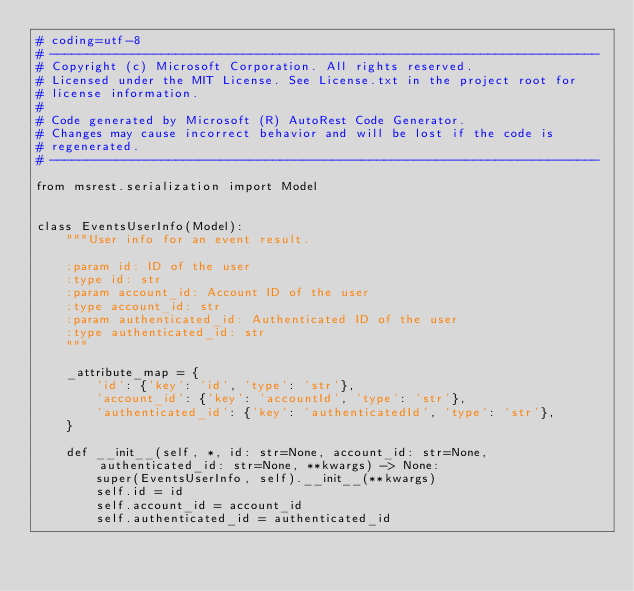<code> <loc_0><loc_0><loc_500><loc_500><_Python_># coding=utf-8
# --------------------------------------------------------------------------
# Copyright (c) Microsoft Corporation. All rights reserved.
# Licensed under the MIT License. See License.txt in the project root for
# license information.
#
# Code generated by Microsoft (R) AutoRest Code Generator.
# Changes may cause incorrect behavior and will be lost if the code is
# regenerated.
# --------------------------------------------------------------------------

from msrest.serialization import Model


class EventsUserInfo(Model):
    """User info for an event result.

    :param id: ID of the user
    :type id: str
    :param account_id: Account ID of the user
    :type account_id: str
    :param authenticated_id: Authenticated ID of the user
    :type authenticated_id: str
    """

    _attribute_map = {
        'id': {'key': 'id', 'type': 'str'},
        'account_id': {'key': 'accountId', 'type': 'str'},
        'authenticated_id': {'key': 'authenticatedId', 'type': 'str'},
    }

    def __init__(self, *, id: str=None, account_id: str=None, authenticated_id: str=None, **kwargs) -> None:
        super(EventsUserInfo, self).__init__(**kwargs)
        self.id = id
        self.account_id = account_id
        self.authenticated_id = authenticated_id
</code> 